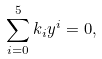<formula> <loc_0><loc_0><loc_500><loc_500>\sum ^ { 5 } _ { i = 0 } k _ { i } y ^ { i } = 0 ,</formula> 